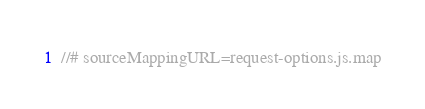Convert code to text. <code><loc_0><loc_0><loc_500><loc_500><_JavaScript_>//# sourceMappingURL=request-options.js.map</code> 